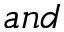Convert formula to latex. <formula><loc_0><loc_0><loc_500><loc_500>a n d</formula> 